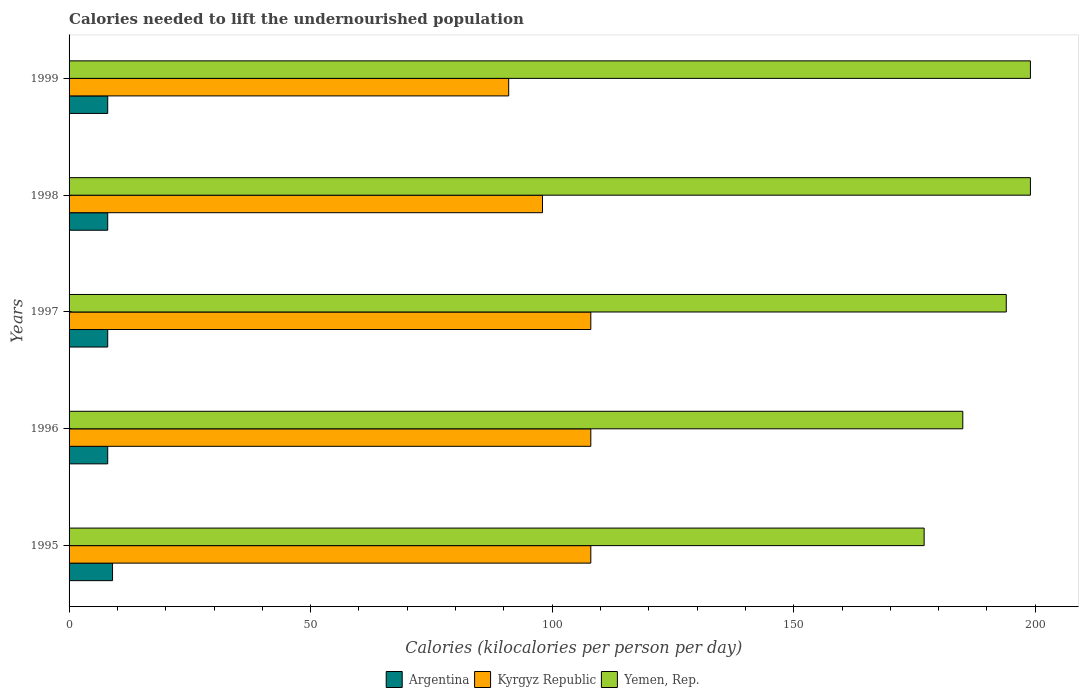How many groups of bars are there?
Provide a succinct answer. 5. Are the number of bars per tick equal to the number of legend labels?
Make the answer very short. Yes. How many bars are there on the 2nd tick from the top?
Your answer should be very brief. 3. What is the total calories needed to lift the undernourished population in Yemen, Rep. in 1998?
Keep it short and to the point. 199. Across all years, what is the maximum total calories needed to lift the undernourished population in Argentina?
Provide a short and direct response. 9. Across all years, what is the minimum total calories needed to lift the undernourished population in Kyrgyz Republic?
Make the answer very short. 91. In which year was the total calories needed to lift the undernourished population in Argentina maximum?
Provide a short and direct response. 1995. In which year was the total calories needed to lift the undernourished population in Kyrgyz Republic minimum?
Offer a terse response. 1999. What is the total total calories needed to lift the undernourished population in Kyrgyz Republic in the graph?
Ensure brevity in your answer.  513. What is the difference between the total calories needed to lift the undernourished population in Kyrgyz Republic in 1997 and that in 1998?
Offer a very short reply. 10. What is the difference between the total calories needed to lift the undernourished population in Kyrgyz Republic in 1996 and the total calories needed to lift the undernourished population in Argentina in 1999?
Give a very brief answer. 100. What is the average total calories needed to lift the undernourished population in Kyrgyz Republic per year?
Your answer should be very brief. 102.6. In the year 1997, what is the difference between the total calories needed to lift the undernourished population in Kyrgyz Republic and total calories needed to lift the undernourished population in Yemen, Rep.?
Offer a terse response. -86. In how many years, is the total calories needed to lift the undernourished population in Argentina greater than 60 kilocalories?
Give a very brief answer. 0. What is the ratio of the total calories needed to lift the undernourished population in Kyrgyz Republic in 1998 to that in 1999?
Make the answer very short. 1.08. What is the difference between the highest and the lowest total calories needed to lift the undernourished population in Yemen, Rep.?
Provide a short and direct response. 22. In how many years, is the total calories needed to lift the undernourished population in Kyrgyz Republic greater than the average total calories needed to lift the undernourished population in Kyrgyz Republic taken over all years?
Make the answer very short. 3. What does the 1st bar from the top in 1998 represents?
Provide a short and direct response. Yemen, Rep. What does the 2nd bar from the bottom in 1999 represents?
Provide a succinct answer. Kyrgyz Republic. Is it the case that in every year, the sum of the total calories needed to lift the undernourished population in Argentina and total calories needed to lift the undernourished population in Kyrgyz Republic is greater than the total calories needed to lift the undernourished population in Yemen, Rep.?
Offer a terse response. No. Are all the bars in the graph horizontal?
Make the answer very short. Yes. Does the graph contain grids?
Offer a terse response. No. What is the title of the graph?
Give a very brief answer. Calories needed to lift the undernourished population. Does "Gabon" appear as one of the legend labels in the graph?
Provide a short and direct response. No. What is the label or title of the X-axis?
Keep it short and to the point. Calories (kilocalories per person per day). What is the label or title of the Y-axis?
Ensure brevity in your answer.  Years. What is the Calories (kilocalories per person per day) of Kyrgyz Republic in 1995?
Offer a very short reply. 108. What is the Calories (kilocalories per person per day) of Yemen, Rep. in 1995?
Ensure brevity in your answer.  177. What is the Calories (kilocalories per person per day) in Kyrgyz Republic in 1996?
Offer a terse response. 108. What is the Calories (kilocalories per person per day) in Yemen, Rep. in 1996?
Provide a short and direct response. 185. What is the Calories (kilocalories per person per day) of Kyrgyz Republic in 1997?
Keep it short and to the point. 108. What is the Calories (kilocalories per person per day) of Yemen, Rep. in 1997?
Offer a very short reply. 194. What is the Calories (kilocalories per person per day) in Kyrgyz Republic in 1998?
Your response must be concise. 98. What is the Calories (kilocalories per person per day) of Yemen, Rep. in 1998?
Make the answer very short. 199. What is the Calories (kilocalories per person per day) in Argentina in 1999?
Your answer should be compact. 8. What is the Calories (kilocalories per person per day) in Kyrgyz Republic in 1999?
Give a very brief answer. 91. What is the Calories (kilocalories per person per day) in Yemen, Rep. in 1999?
Your response must be concise. 199. Across all years, what is the maximum Calories (kilocalories per person per day) of Kyrgyz Republic?
Your answer should be compact. 108. Across all years, what is the maximum Calories (kilocalories per person per day) in Yemen, Rep.?
Provide a short and direct response. 199. Across all years, what is the minimum Calories (kilocalories per person per day) in Kyrgyz Republic?
Your answer should be compact. 91. Across all years, what is the minimum Calories (kilocalories per person per day) of Yemen, Rep.?
Your response must be concise. 177. What is the total Calories (kilocalories per person per day) of Kyrgyz Republic in the graph?
Your response must be concise. 513. What is the total Calories (kilocalories per person per day) of Yemen, Rep. in the graph?
Your answer should be very brief. 954. What is the difference between the Calories (kilocalories per person per day) of Kyrgyz Republic in 1995 and that in 1996?
Provide a short and direct response. 0. What is the difference between the Calories (kilocalories per person per day) in Yemen, Rep. in 1995 and that in 1996?
Your answer should be compact. -8. What is the difference between the Calories (kilocalories per person per day) of Yemen, Rep. in 1995 and that in 1997?
Make the answer very short. -17. What is the difference between the Calories (kilocalories per person per day) in Argentina in 1995 and that in 1998?
Provide a short and direct response. 1. What is the difference between the Calories (kilocalories per person per day) of Kyrgyz Republic in 1995 and that in 1998?
Your response must be concise. 10. What is the difference between the Calories (kilocalories per person per day) of Yemen, Rep. in 1995 and that in 1998?
Offer a terse response. -22. What is the difference between the Calories (kilocalories per person per day) of Yemen, Rep. in 1995 and that in 1999?
Provide a succinct answer. -22. What is the difference between the Calories (kilocalories per person per day) in Kyrgyz Republic in 1996 and that in 1997?
Your response must be concise. 0. What is the difference between the Calories (kilocalories per person per day) of Yemen, Rep. in 1996 and that in 1997?
Ensure brevity in your answer.  -9. What is the difference between the Calories (kilocalories per person per day) of Argentina in 1996 and that in 1998?
Keep it short and to the point. 0. What is the difference between the Calories (kilocalories per person per day) in Kyrgyz Republic in 1996 and that in 1998?
Give a very brief answer. 10. What is the difference between the Calories (kilocalories per person per day) in Yemen, Rep. in 1997 and that in 1998?
Ensure brevity in your answer.  -5. What is the difference between the Calories (kilocalories per person per day) in Argentina in 1997 and that in 1999?
Your answer should be very brief. 0. What is the difference between the Calories (kilocalories per person per day) in Yemen, Rep. in 1997 and that in 1999?
Offer a very short reply. -5. What is the difference between the Calories (kilocalories per person per day) in Argentina in 1998 and that in 1999?
Make the answer very short. 0. What is the difference between the Calories (kilocalories per person per day) of Argentina in 1995 and the Calories (kilocalories per person per day) of Kyrgyz Republic in 1996?
Provide a short and direct response. -99. What is the difference between the Calories (kilocalories per person per day) in Argentina in 1995 and the Calories (kilocalories per person per day) in Yemen, Rep. in 1996?
Make the answer very short. -176. What is the difference between the Calories (kilocalories per person per day) in Kyrgyz Republic in 1995 and the Calories (kilocalories per person per day) in Yemen, Rep. in 1996?
Provide a succinct answer. -77. What is the difference between the Calories (kilocalories per person per day) in Argentina in 1995 and the Calories (kilocalories per person per day) in Kyrgyz Republic in 1997?
Your answer should be very brief. -99. What is the difference between the Calories (kilocalories per person per day) in Argentina in 1995 and the Calories (kilocalories per person per day) in Yemen, Rep. in 1997?
Your answer should be compact. -185. What is the difference between the Calories (kilocalories per person per day) in Kyrgyz Republic in 1995 and the Calories (kilocalories per person per day) in Yemen, Rep. in 1997?
Ensure brevity in your answer.  -86. What is the difference between the Calories (kilocalories per person per day) of Argentina in 1995 and the Calories (kilocalories per person per day) of Kyrgyz Republic in 1998?
Your answer should be compact. -89. What is the difference between the Calories (kilocalories per person per day) in Argentina in 1995 and the Calories (kilocalories per person per day) in Yemen, Rep. in 1998?
Keep it short and to the point. -190. What is the difference between the Calories (kilocalories per person per day) in Kyrgyz Republic in 1995 and the Calories (kilocalories per person per day) in Yemen, Rep. in 1998?
Your answer should be very brief. -91. What is the difference between the Calories (kilocalories per person per day) in Argentina in 1995 and the Calories (kilocalories per person per day) in Kyrgyz Republic in 1999?
Provide a short and direct response. -82. What is the difference between the Calories (kilocalories per person per day) of Argentina in 1995 and the Calories (kilocalories per person per day) of Yemen, Rep. in 1999?
Offer a very short reply. -190. What is the difference between the Calories (kilocalories per person per day) of Kyrgyz Republic in 1995 and the Calories (kilocalories per person per day) of Yemen, Rep. in 1999?
Provide a short and direct response. -91. What is the difference between the Calories (kilocalories per person per day) in Argentina in 1996 and the Calories (kilocalories per person per day) in Kyrgyz Republic in 1997?
Provide a short and direct response. -100. What is the difference between the Calories (kilocalories per person per day) in Argentina in 1996 and the Calories (kilocalories per person per day) in Yemen, Rep. in 1997?
Provide a succinct answer. -186. What is the difference between the Calories (kilocalories per person per day) in Kyrgyz Republic in 1996 and the Calories (kilocalories per person per day) in Yemen, Rep. in 1997?
Provide a short and direct response. -86. What is the difference between the Calories (kilocalories per person per day) in Argentina in 1996 and the Calories (kilocalories per person per day) in Kyrgyz Republic in 1998?
Keep it short and to the point. -90. What is the difference between the Calories (kilocalories per person per day) in Argentina in 1996 and the Calories (kilocalories per person per day) in Yemen, Rep. in 1998?
Your answer should be very brief. -191. What is the difference between the Calories (kilocalories per person per day) of Kyrgyz Republic in 1996 and the Calories (kilocalories per person per day) of Yemen, Rep. in 1998?
Ensure brevity in your answer.  -91. What is the difference between the Calories (kilocalories per person per day) in Argentina in 1996 and the Calories (kilocalories per person per day) in Kyrgyz Republic in 1999?
Give a very brief answer. -83. What is the difference between the Calories (kilocalories per person per day) of Argentina in 1996 and the Calories (kilocalories per person per day) of Yemen, Rep. in 1999?
Offer a very short reply. -191. What is the difference between the Calories (kilocalories per person per day) of Kyrgyz Republic in 1996 and the Calories (kilocalories per person per day) of Yemen, Rep. in 1999?
Your answer should be very brief. -91. What is the difference between the Calories (kilocalories per person per day) of Argentina in 1997 and the Calories (kilocalories per person per day) of Kyrgyz Republic in 1998?
Offer a very short reply. -90. What is the difference between the Calories (kilocalories per person per day) in Argentina in 1997 and the Calories (kilocalories per person per day) in Yemen, Rep. in 1998?
Offer a terse response. -191. What is the difference between the Calories (kilocalories per person per day) of Kyrgyz Republic in 1997 and the Calories (kilocalories per person per day) of Yemen, Rep. in 1998?
Give a very brief answer. -91. What is the difference between the Calories (kilocalories per person per day) in Argentina in 1997 and the Calories (kilocalories per person per day) in Kyrgyz Republic in 1999?
Give a very brief answer. -83. What is the difference between the Calories (kilocalories per person per day) of Argentina in 1997 and the Calories (kilocalories per person per day) of Yemen, Rep. in 1999?
Provide a short and direct response. -191. What is the difference between the Calories (kilocalories per person per day) in Kyrgyz Republic in 1997 and the Calories (kilocalories per person per day) in Yemen, Rep. in 1999?
Ensure brevity in your answer.  -91. What is the difference between the Calories (kilocalories per person per day) in Argentina in 1998 and the Calories (kilocalories per person per day) in Kyrgyz Republic in 1999?
Provide a short and direct response. -83. What is the difference between the Calories (kilocalories per person per day) of Argentina in 1998 and the Calories (kilocalories per person per day) of Yemen, Rep. in 1999?
Your response must be concise. -191. What is the difference between the Calories (kilocalories per person per day) in Kyrgyz Republic in 1998 and the Calories (kilocalories per person per day) in Yemen, Rep. in 1999?
Your response must be concise. -101. What is the average Calories (kilocalories per person per day) of Argentina per year?
Make the answer very short. 8.2. What is the average Calories (kilocalories per person per day) in Kyrgyz Republic per year?
Make the answer very short. 102.6. What is the average Calories (kilocalories per person per day) of Yemen, Rep. per year?
Give a very brief answer. 190.8. In the year 1995, what is the difference between the Calories (kilocalories per person per day) of Argentina and Calories (kilocalories per person per day) of Kyrgyz Republic?
Your answer should be very brief. -99. In the year 1995, what is the difference between the Calories (kilocalories per person per day) in Argentina and Calories (kilocalories per person per day) in Yemen, Rep.?
Offer a very short reply. -168. In the year 1995, what is the difference between the Calories (kilocalories per person per day) of Kyrgyz Republic and Calories (kilocalories per person per day) of Yemen, Rep.?
Provide a succinct answer. -69. In the year 1996, what is the difference between the Calories (kilocalories per person per day) of Argentina and Calories (kilocalories per person per day) of Kyrgyz Republic?
Offer a terse response. -100. In the year 1996, what is the difference between the Calories (kilocalories per person per day) of Argentina and Calories (kilocalories per person per day) of Yemen, Rep.?
Your answer should be compact. -177. In the year 1996, what is the difference between the Calories (kilocalories per person per day) in Kyrgyz Republic and Calories (kilocalories per person per day) in Yemen, Rep.?
Keep it short and to the point. -77. In the year 1997, what is the difference between the Calories (kilocalories per person per day) in Argentina and Calories (kilocalories per person per day) in Kyrgyz Republic?
Offer a terse response. -100. In the year 1997, what is the difference between the Calories (kilocalories per person per day) in Argentina and Calories (kilocalories per person per day) in Yemen, Rep.?
Your response must be concise. -186. In the year 1997, what is the difference between the Calories (kilocalories per person per day) in Kyrgyz Republic and Calories (kilocalories per person per day) in Yemen, Rep.?
Give a very brief answer. -86. In the year 1998, what is the difference between the Calories (kilocalories per person per day) in Argentina and Calories (kilocalories per person per day) in Kyrgyz Republic?
Provide a short and direct response. -90. In the year 1998, what is the difference between the Calories (kilocalories per person per day) in Argentina and Calories (kilocalories per person per day) in Yemen, Rep.?
Keep it short and to the point. -191. In the year 1998, what is the difference between the Calories (kilocalories per person per day) in Kyrgyz Republic and Calories (kilocalories per person per day) in Yemen, Rep.?
Your response must be concise. -101. In the year 1999, what is the difference between the Calories (kilocalories per person per day) in Argentina and Calories (kilocalories per person per day) in Kyrgyz Republic?
Your answer should be compact. -83. In the year 1999, what is the difference between the Calories (kilocalories per person per day) of Argentina and Calories (kilocalories per person per day) of Yemen, Rep.?
Keep it short and to the point. -191. In the year 1999, what is the difference between the Calories (kilocalories per person per day) of Kyrgyz Republic and Calories (kilocalories per person per day) of Yemen, Rep.?
Give a very brief answer. -108. What is the ratio of the Calories (kilocalories per person per day) in Yemen, Rep. in 1995 to that in 1996?
Your response must be concise. 0.96. What is the ratio of the Calories (kilocalories per person per day) of Argentina in 1995 to that in 1997?
Give a very brief answer. 1.12. What is the ratio of the Calories (kilocalories per person per day) in Kyrgyz Republic in 1995 to that in 1997?
Provide a succinct answer. 1. What is the ratio of the Calories (kilocalories per person per day) of Yemen, Rep. in 1995 to that in 1997?
Your response must be concise. 0.91. What is the ratio of the Calories (kilocalories per person per day) in Kyrgyz Republic in 1995 to that in 1998?
Your response must be concise. 1.1. What is the ratio of the Calories (kilocalories per person per day) in Yemen, Rep. in 1995 to that in 1998?
Keep it short and to the point. 0.89. What is the ratio of the Calories (kilocalories per person per day) in Argentina in 1995 to that in 1999?
Give a very brief answer. 1.12. What is the ratio of the Calories (kilocalories per person per day) of Kyrgyz Republic in 1995 to that in 1999?
Your answer should be very brief. 1.19. What is the ratio of the Calories (kilocalories per person per day) of Yemen, Rep. in 1995 to that in 1999?
Ensure brevity in your answer.  0.89. What is the ratio of the Calories (kilocalories per person per day) in Yemen, Rep. in 1996 to that in 1997?
Ensure brevity in your answer.  0.95. What is the ratio of the Calories (kilocalories per person per day) of Kyrgyz Republic in 1996 to that in 1998?
Provide a succinct answer. 1.1. What is the ratio of the Calories (kilocalories per person per day) in Yemen, Rep. in 1996 to that in 1998?
Keep it short and to the point. 0.93. What is the ratio of the Calories (kilocalories per person per day) in Kyrgyz Republic in 1996 to that in 1999?
Your answer should be compact. 1.19. What is the ratio of the Calories (kilocalories per person per day) in Yemen, Rep. in 1996 to that in 1999?
Your answer should be very brief. 0.93. What is the ratio of the Calories (kilocalories per person per day) in Argentina in 1997 to that in 1998?
Offer a terse response. 1. What is the ratio of the Calories (kilocalories per person per day) in Kyrgyz Republic in 1997 to that in 1998?
Your answer should be compact. 1.1. What is the ratio of the Calories (kilocalories per person per day) in Yemen, Rep. in 1997 to that in 1998?
Provide a succinct answer. 0.97. What is the ratio of the Calories (kilocalories per person per day) of Argentina in 1997 to that in 1999?
Offer a very short reply. 1. What is the ratio of the Calories (kilocalories per person per day) in Kyrgyz Republic in 1997 to that in 1999?
Your response must be concise. 1.19. What is the ratio of the Calories (kilocalories per person per day) in Yemen, Rep. in 1997 to that in 1999?
Offer a very short reply. 0.97. What is the ratio of the Calories (kilocalories per person per day) of Argentina in 1998 to that in 1999?
Your answer should be very brief. 1. What is the ratio of the Calories (kilocalories per person per day) of Kyrgyz Republic in 1998 to that in 1999?
Offer a terse response. 1.08. What is the ratio of the Calories (kilocalories per person per day) in Yemen, Rep. in 1998 to that in 1999?
Your answer should be compact. 1. What is the difference between the highest and the lowest Calories (kilocalories per person per day) of Argentina?
Keep it short and to the point. 1. What is the difference between the highest and the lowest Calories (kilocalories per person per day) in Kyrgyz Republic?
Offer a very short reply. 17. What is the difference between the highest and the lowest Calories (kilocalories per person per day) of Yemen, Rep.?
Offer a very short reply. 22. 